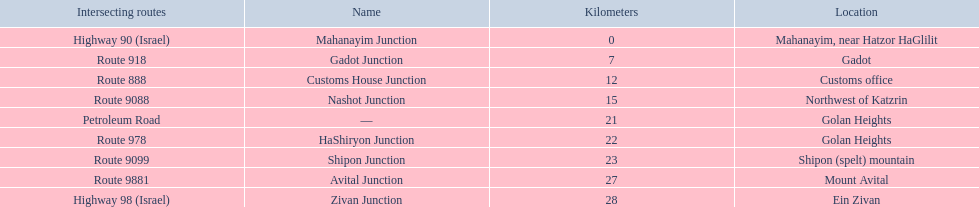How many kilometers away is shipon junction? 23. How many kilometers away is avital junction? 27. Which one is closer to nashot junction? Shipon Junction. 